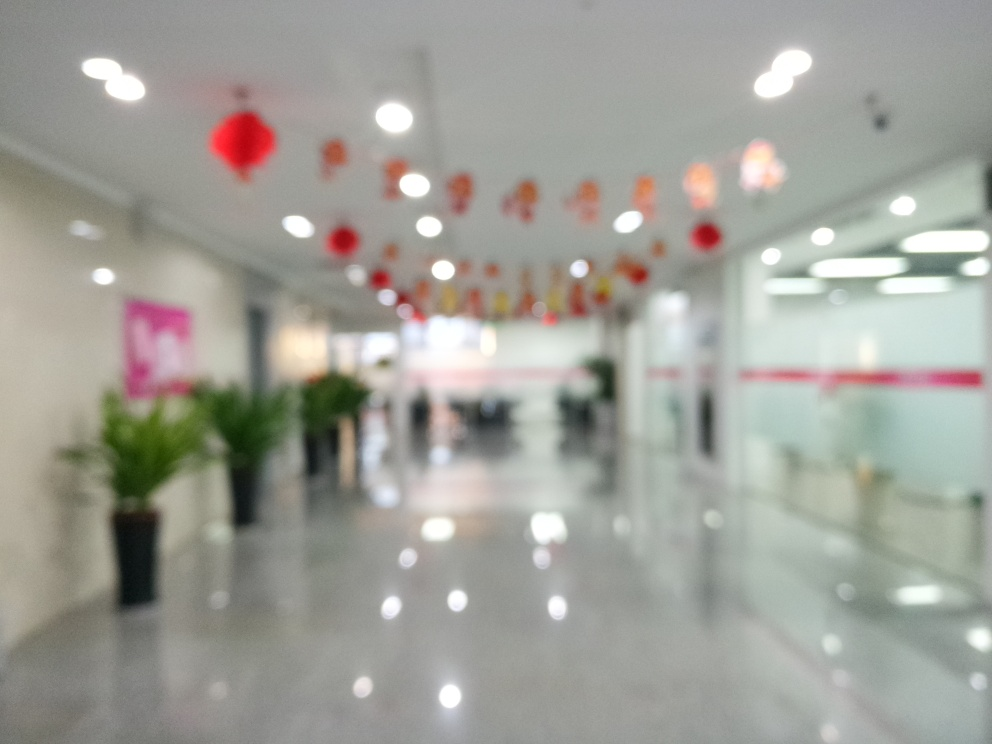What could be the possible reason for the image being blurred? The blurriness of the image could be intentional, aiming to evoke a dreamy or ethereal quality, or it could be the result of a technical issue, such as camera shake, incorrect focus settings, or movement during the exposure. It adds an element of mystery or imperfection, drawing attention away from specific details and more towards the overall mood. 